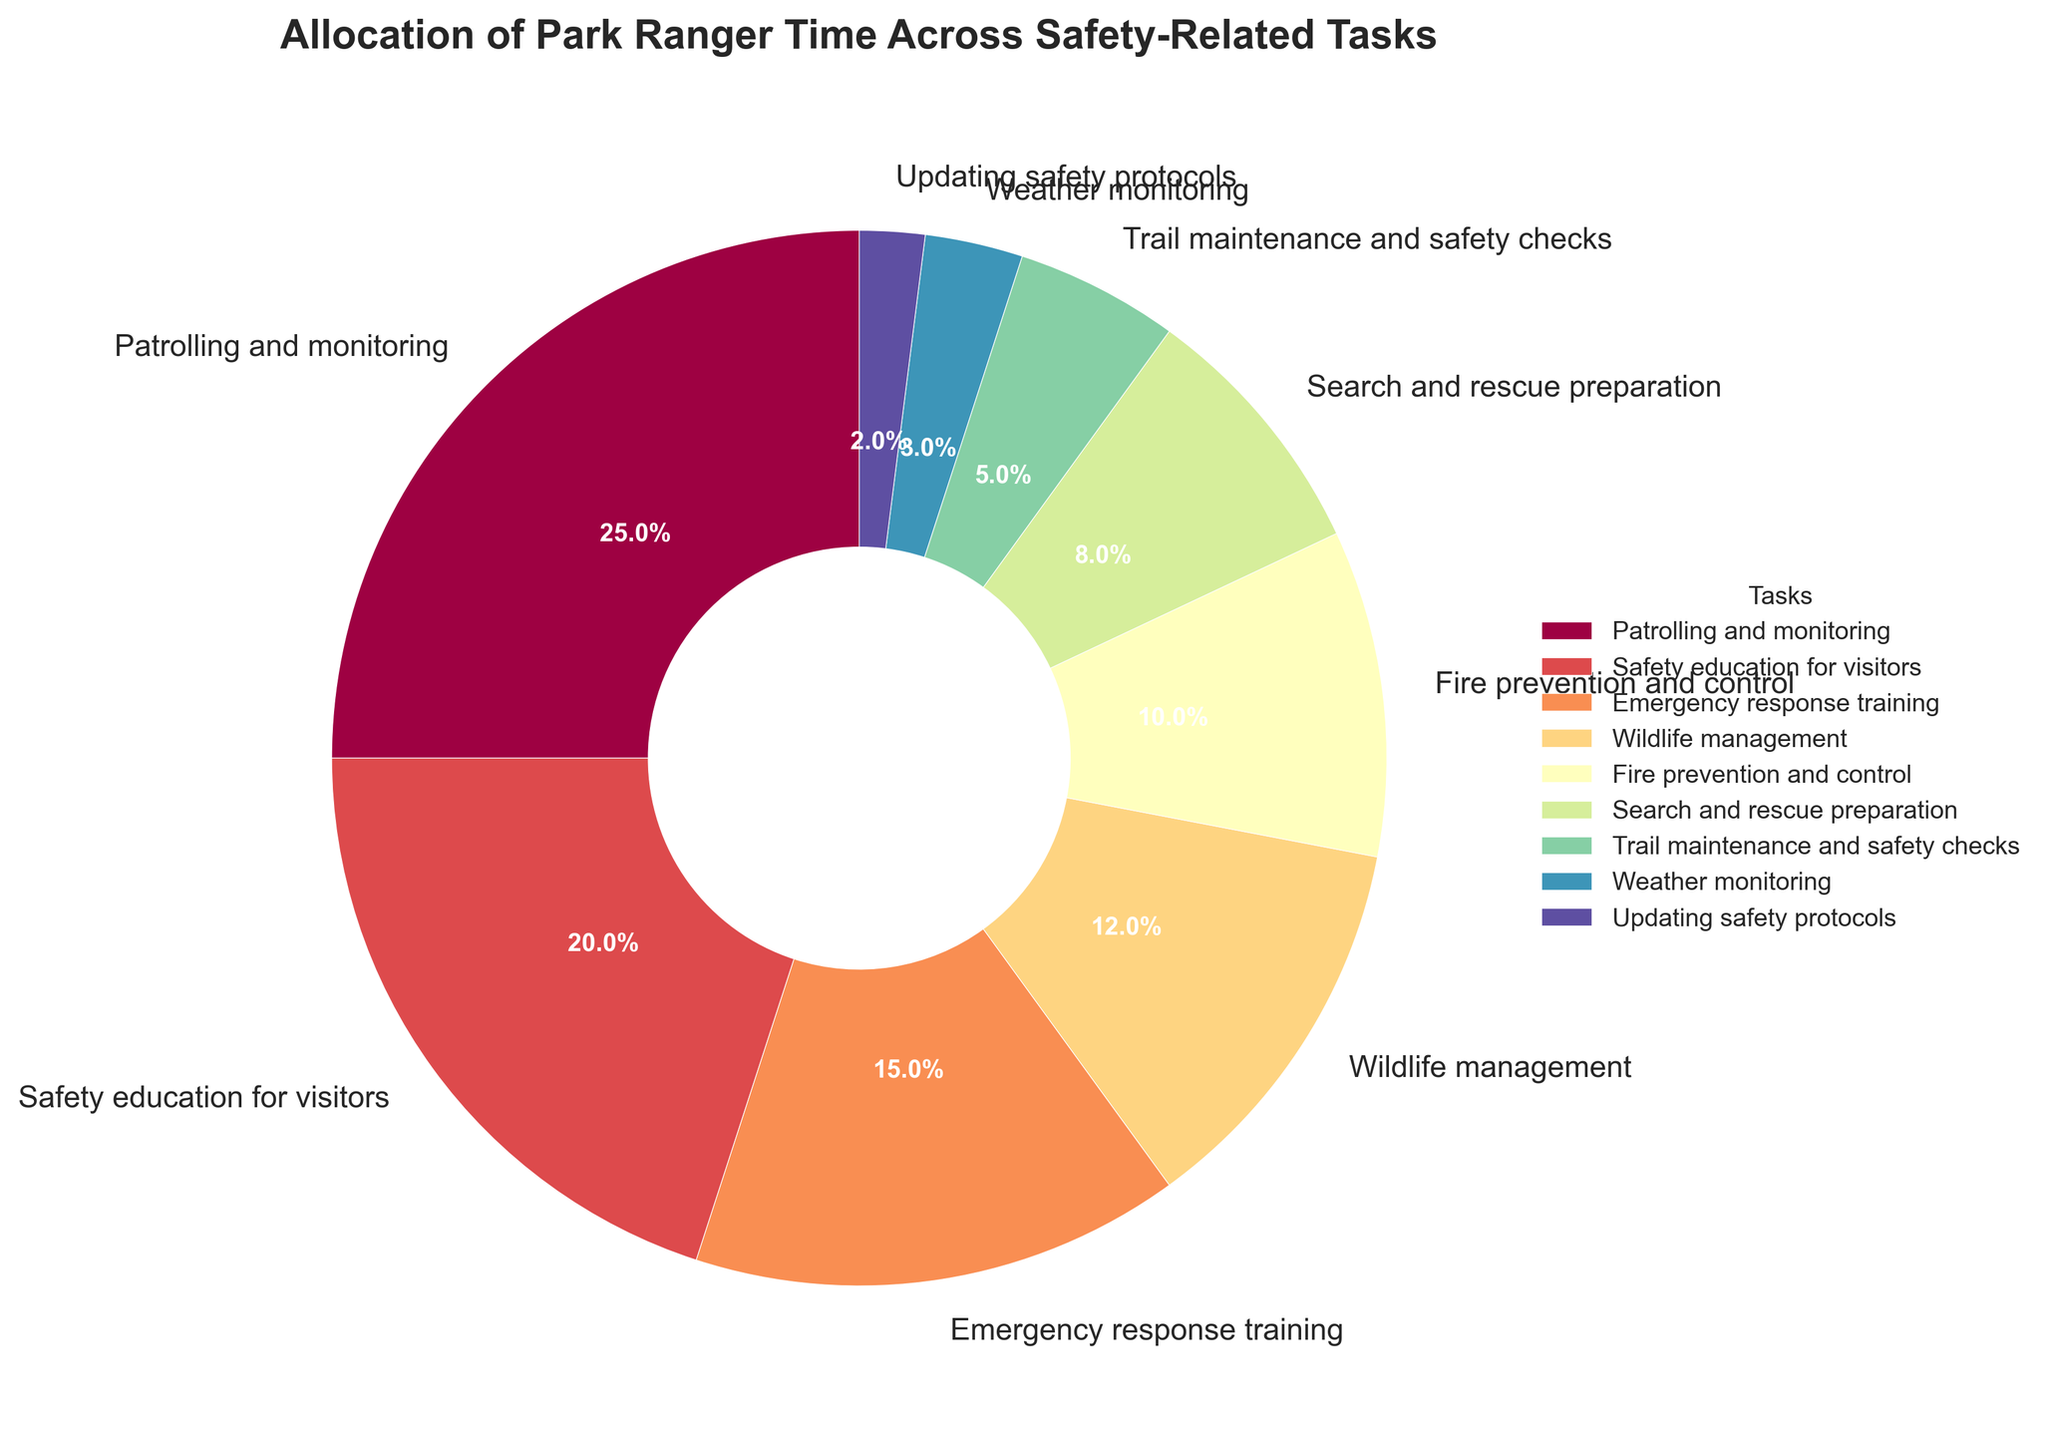Which task takes up the largest portion of park rangers' time? The task with the largest portion will have the highest percentage on the pie chart. Patrolling and monitoring has the largest slice, which is 25%.
Answer: Patrolling and monitoring How much time do park rangers spend on safety education and emergency response training combined? Add the percentages for safety education for visitors (20%) and emergency response training (15%). 20% + 15% = 35%.
Answer: 35% Which task occupies more time, wildlife management or fire prevention and control? Compare the percentages of wildlife management (12%) and fire prevention and control (10%). Wildlife management is higher.
Answer: Wildlife management How does the time spent on trail maintenance and safety checks compare to the time spent on weather monitoring? Compare the percentages for trail maintenance and safety checks (5%) and weather monitoring (3%). Trail maintenance and safety checks have a higher percentage.
Answer: Trail maintenance and safety checks What is the difference between the time allocated to search and rescue preparation and updating safety protocols? Subtract the percentage of updating safety protocols (2%) from search and rescue preparation (8%). 8% - 2% = 6%.
Answer: 6% Which task(s) take up less than 5% of park rangers' time? Look for the tasks with percentages less than 5%. Both weather monitoring (3%) and updating safety protocols (2%) fit this criterion.
Answer: Weather monitoring, Updating safety protocols Excluding the largest and smallest time allocations, what is the average percentage of the remaining tasks? The largest is Patrolling and monitoring (25%) and the smallest is Updating safety protocols (2%). Exclude these and average the remaining: (20% + 15% + 12% + 10% + 8% + 5% + 3%) = 73%, divided by 7 tasks. 73% / 7 ≈ 10.43%.
Answer: 10.43% How much more time do park rangers spend on patrolling and monitoring than on trail maintenance and safety checks? Subtract the percentage of trail maintenance and safety checks (5%) from patrolling and monitoring (25%). 25% - 5% = 20%.
Answer: 20% Is there any task where park rangers spend exactly half of the time they do on safety education for visitors? Safety education for visitors takes 20% of the time. Half of 20% is 10%. Fire prevention and control is allotted exactly 10%.
Answer: Fire prevention and control If the total time is 100 hours, how many hours are allocated to fire prevention and control, and weather monitoring combined? Combined percentage for fire prevention and control (10%) and weather monitoring (3%) is 13%. 13% of 100 hours is 13 hours.
Answer: 13 hours 